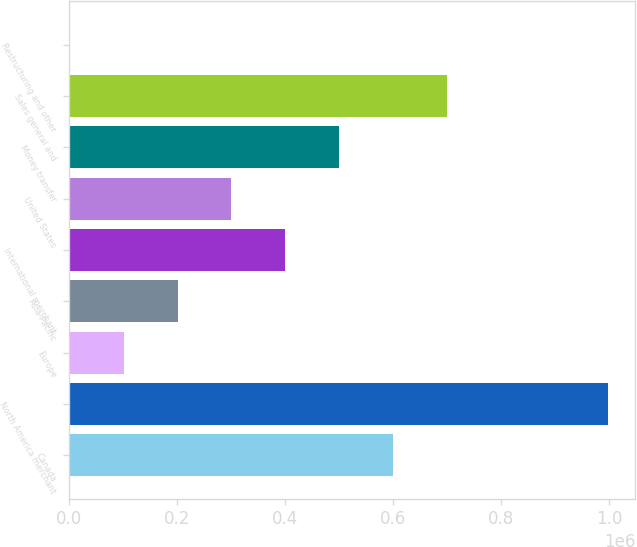Convert chart. <chart><loc_0><loc_0><loc_500><loc_500><bar_chart><fcel>Canada<fcel>North America merchant<fcel>Europe<fcel>Asia-Pacific<fcel>International merchant<fcel>United States<fcel>Money transfer<fcel>Sales general and<fcel>Restructuring and other<nl><fcel>599605<fcel>998464<fcel>101032<fcel>200746<fcel>400176<fcel>300461<fcel>499890<fcel>699320<fcel>1317<nl></chart> 